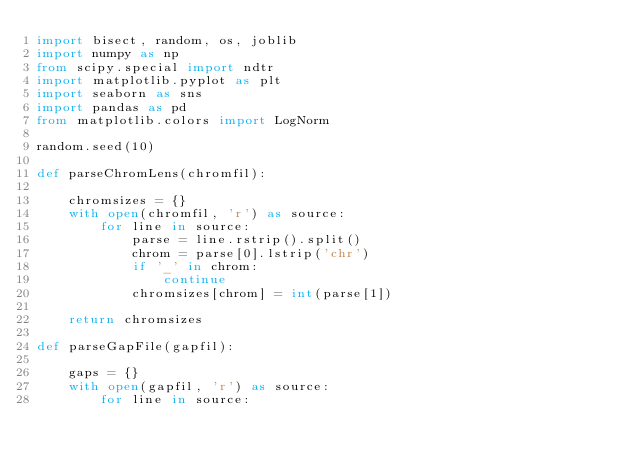<code> <loc_0><loc_0><loc_500><loc_500><_Python_>import bisect, random, os, joblib
import numpy as np
from scipy.special import ndtr
import matplotlib.pyplot as plt
import seaborn as sns
import pandas as pd
from matplotlib.colors import LogNorm

random.seed(10)

def parseChromLens(chromfil):
    
    chromsizes = {}
    with open(chromfil, 'r') as source:
        for line in source:
            parse = line.rstrip().split()
            chrom = parse[0].lstrip('chr')
            if '_' in chrom:
                continue
            chromsizes[chrom] = int(parse[1])
            
    return chromsizes

def parseGapFile(gapfil):
    
    gaps = {}
    with open(gapfil, 'r') as source:
        for line in source:</code> 